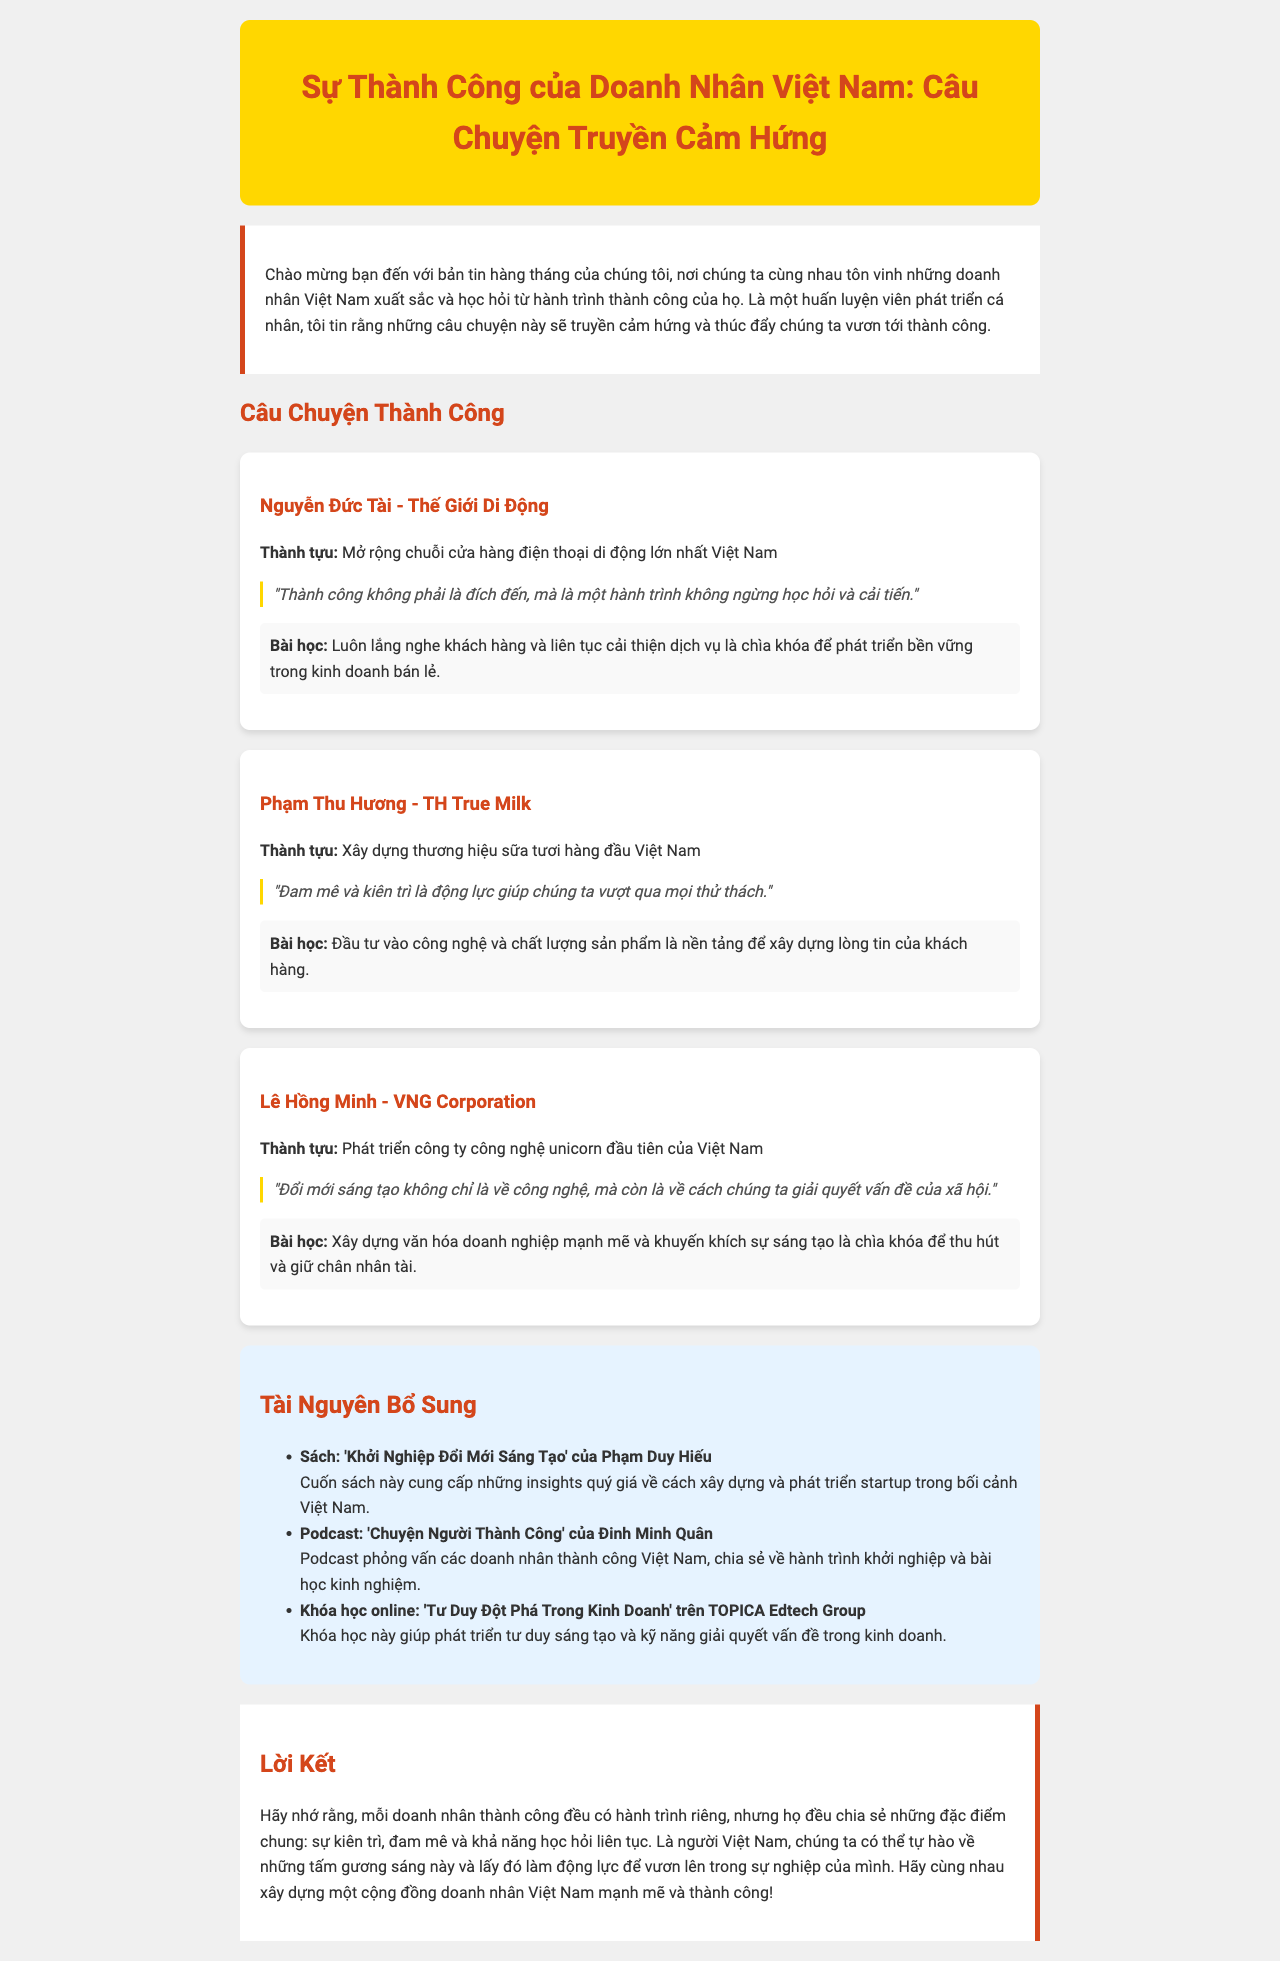what is the title of the newsletter? The title of the newsletter is mentioned at the top of the document.
Answer: Sự Thành Công của Doanh Nhân Việt Nam: Câu Chuyện Truyền Cảm Hứng who is the first entrepreneur featured in the success stories? The first entrepreneur's name and company are provided in the success story section.
Answer: Nguyễn Đức Tài what is the achievement of Phạm Thu Hương? The specific achievement of Phạm Thu Hương is detailed in her success story.
Answer: Xây dựng thương hiệu sữa tươi hàng đầu Việt Nam what lesson did Lê Hồng Minh share? The lesson learned by Lê Hồng Minh is stated in his success story.
Answer: Xây dựng văn hóa doanh nghiệp mạnh mẽ và khuyến khích sự sáng tạo là chìa khóa để thu hút và giữ chân nhân tài how many additional resources are listed in the document? The document contains a specific section listing additional resources with individual entries.
Answer: 3 what motivates Phạm Thu Hương according to her quote? The quote provided gives insight into what drives her in her entrepreneurial journey.
Answer: Đam mê và kiên trì what color is used for the newsletter header? The color of the header is mentioned or can be deduced from the description of its style.
Answer: vàng what type of course is mentioned in the additional resources? The additional resources section includes different types of resources, including online courses.
Answer: Khóa học online who is the author of the recommended book? The additional resources section lists the author of the recommended book specifically.
Answer: Phạm Duy Hiếu 